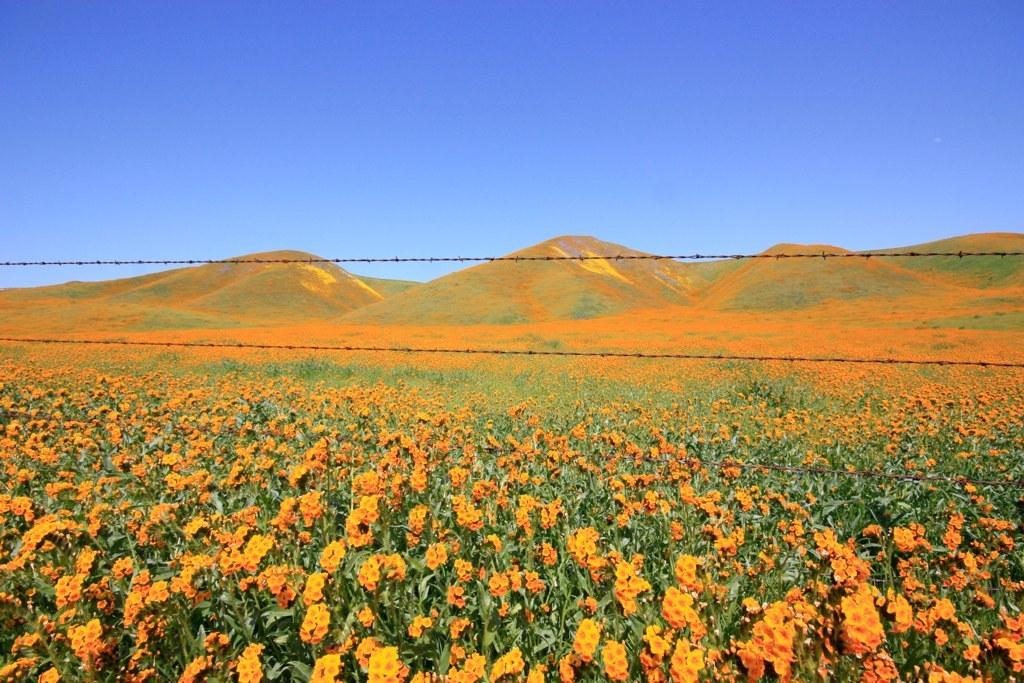What type of natural elements can be seen in the image? There are flowers and mountains visible in the image. What is the color of the sky in the image? The sky is blue and visible at the top of the image. What is the price of the cherry in the image? There is no cherry present in the image, so it is not possible to determine its price. Is there a town visible in the image? The image does not show a town; it features flowers, mountains, and a blue sky. 